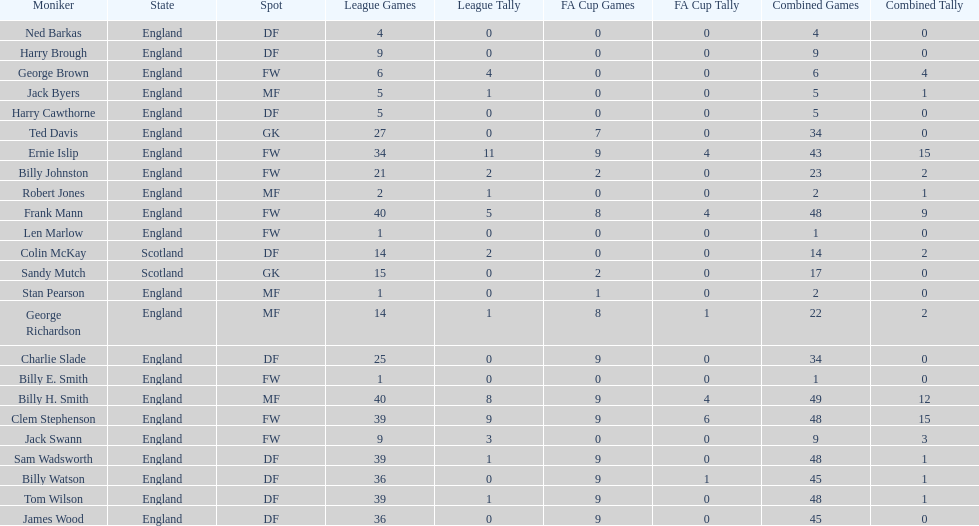How many players are fws? 8. 